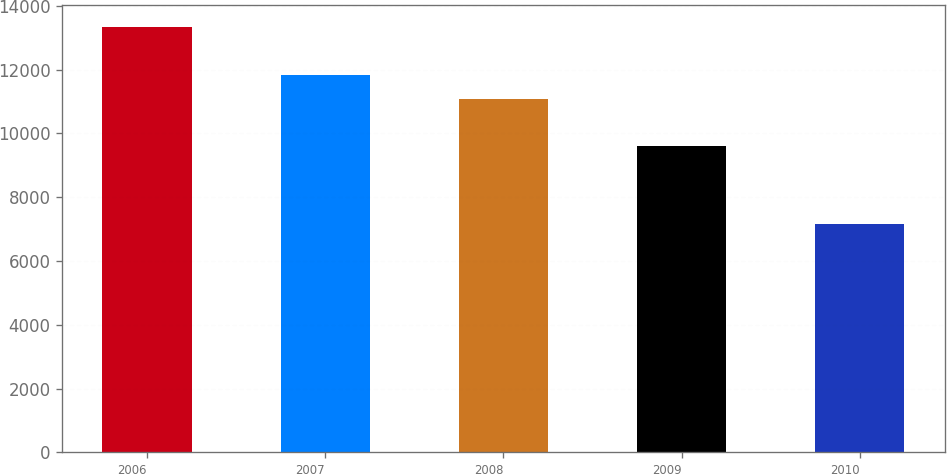Convert chart. <chart><loc_0><loc_0><loc_500><loc_500><bar_chart><fcel>2006<fcel>2007<fcel>2008<fcel>2009<fcel>2010<nl><fcel>13349<fcel>11831<fcel>11085<fcel>9597<fcel>7166<nl></chart> 